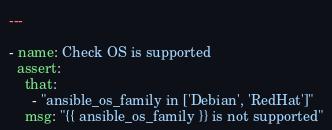Convert code to text. <code><loc_0><loc_0><loc_500><loc_500><_YAML_>---

- name: Check OS is supported
  assert:
    that:
      - "ansible_os_family in ['Debian', 'RedHat']"
    msg: "{{ ansible_os_family }} is not supported"
</code> 